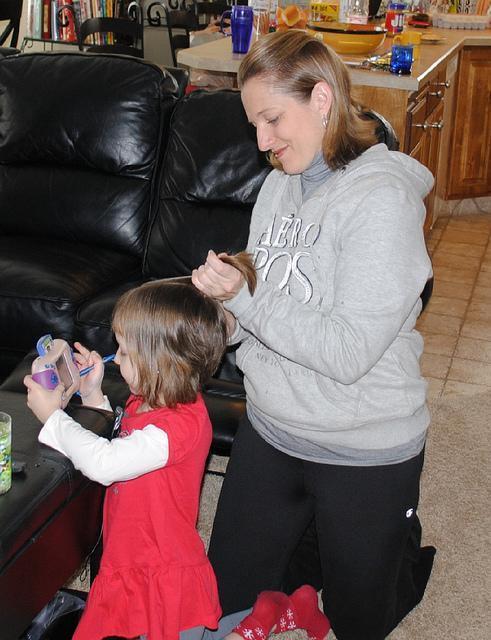How many people can you see?
Give a very brief answer. 2. 